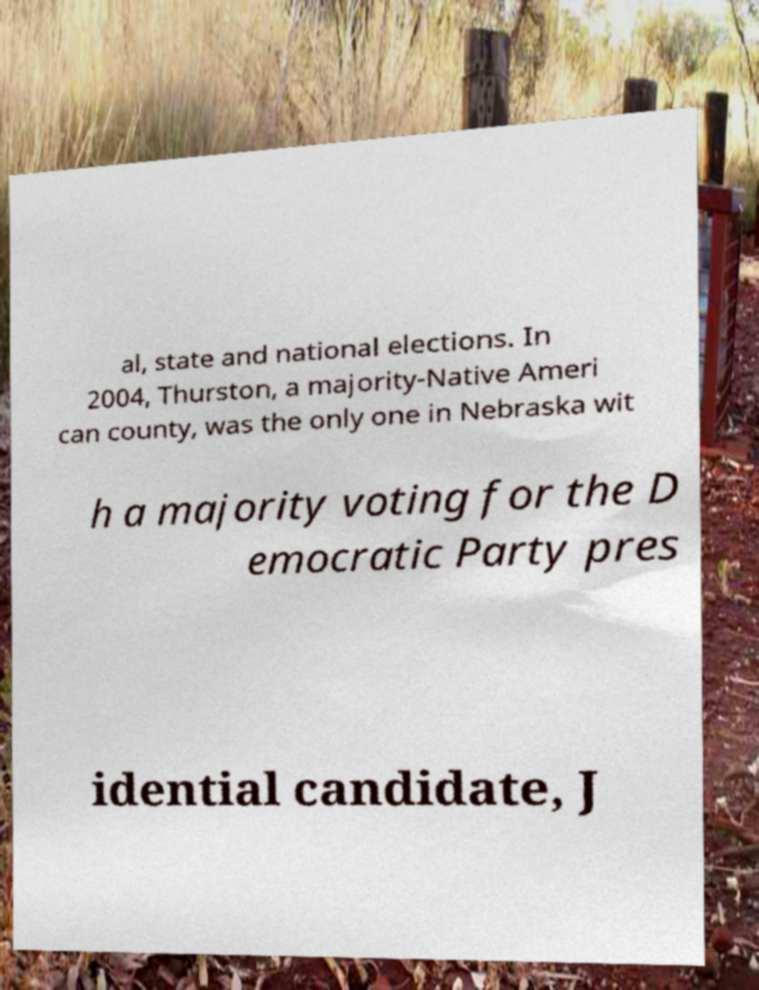I need the written content from this picture converted into text. Can you do that? al, state and national elections. In 2004, Thurston, a majority-Native Ameri can county, was the only one in Nebraska wit h a majority voting for the D emocratic Party pres idential candidate, J 